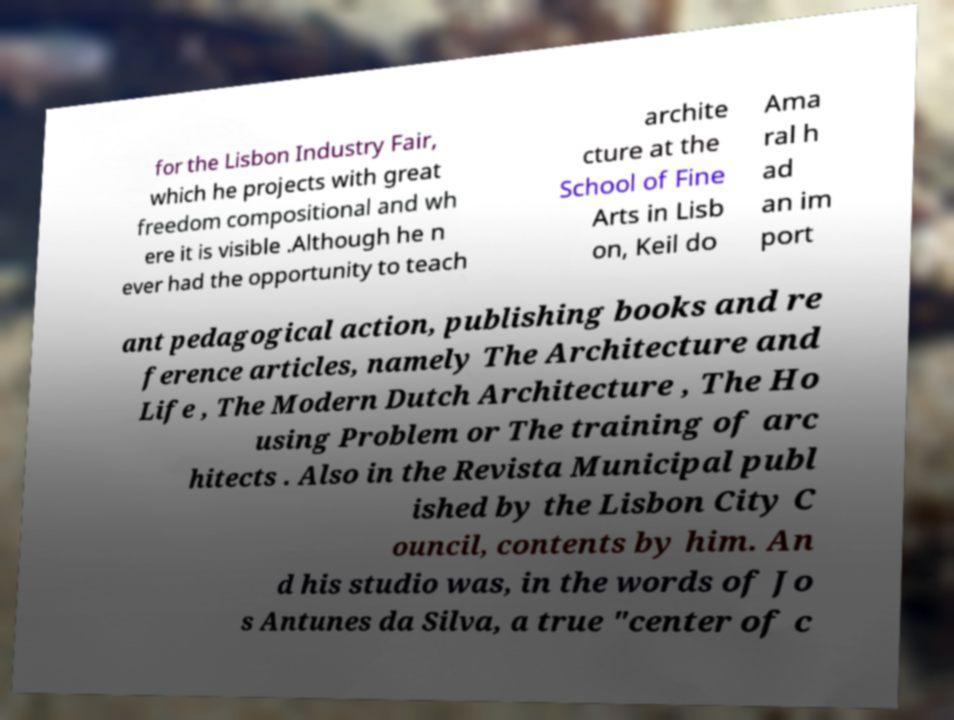Please read and relay the text visible in this image. What does it say? for the Lisbon Industry Fair, which he projects with great freedom compositional and wh ere it is visible .Although he n ever had the opportunity to teach archite cture at the School of Fine Arts in Lisb on, Keil do Ama ral h ad an im port ant pedagogical action, publishing books and re ference articles, namely The Architecture and Life , The Modern Dutch Architecture , The Ho using Problem or The training of arc hitects . Also in the Revista Municipal publ ished by the Lisbon City C ouncil, contents by him. An d his studio was, in the words of Jo s Antunes da Silva, a true "center of c 